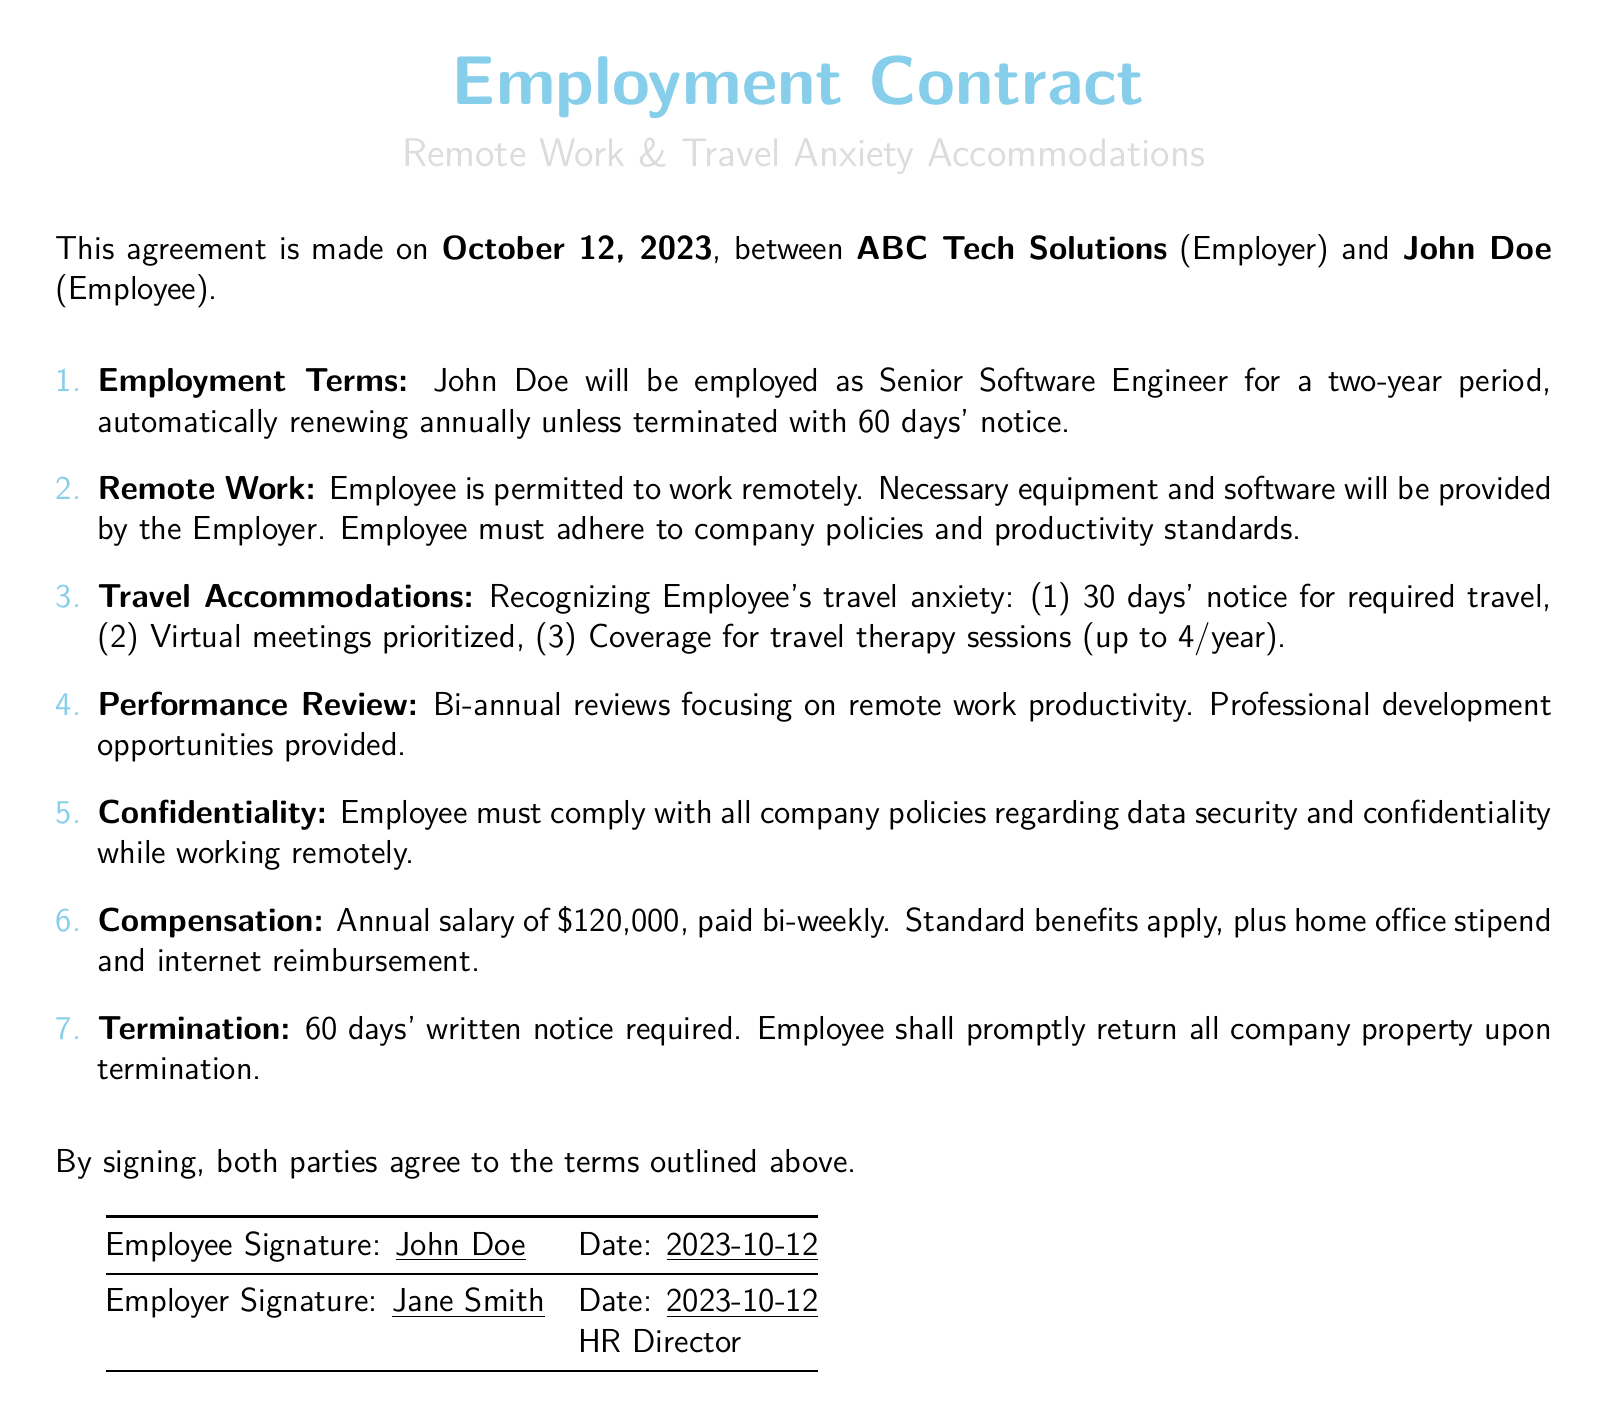What is the duration of the employment? The employment duration is specified as a two-year period in the document.
Answer: two-year period Who is the employer? The document clearly states that the employer is ABC Tech Solutions.
Answer: ABC Tech Solutions What is the annual salary? The annual salary is provided as part of the compensation section in the document.
Answer: $120,000 How many travel therapy sessions are covered per year? The document states that up to 4 travel therapy sessions are covered each year.
Answer: 4 What is required for termination? The document specifies that a 60 days' written notice is required for termination.
Answer: 60 days' written notice What position is John Doe hired for? The employment contract lists the position John Doe is hired for under employment terms.
Answer: Senior Software Engineer How often are performance reviews conducted? The frequency of performance reviews is indicated in the document as bi-annual.
Answer: bi-annual What must be returned upon termination? The document mentions that all company property must be returned upon termination.
Answer: all company property 